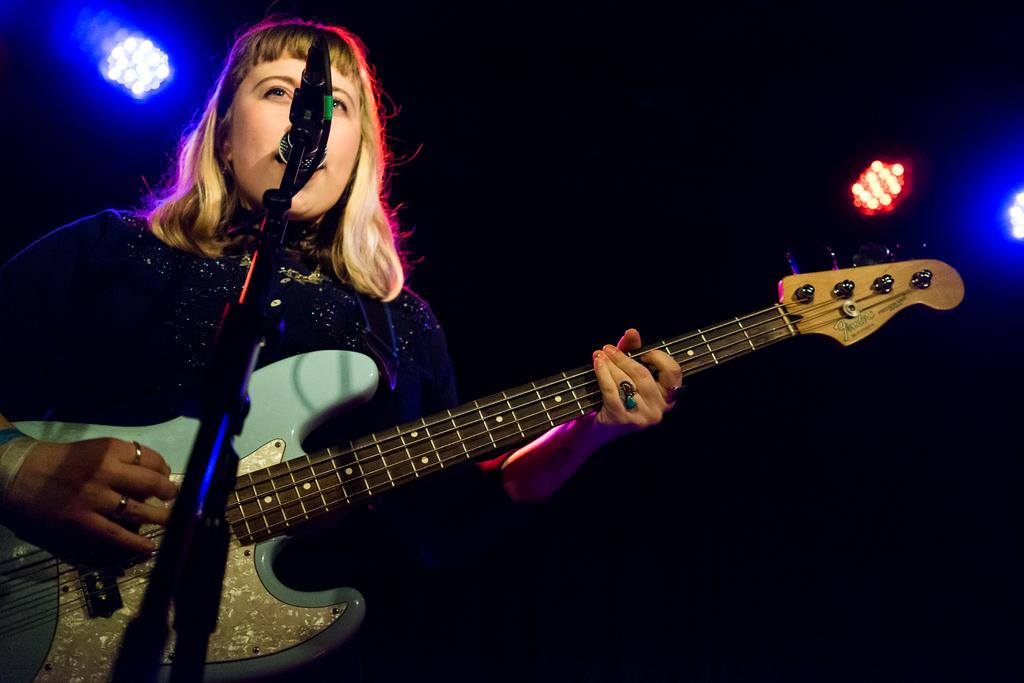What can be seen at the top of the image? There are lights visible at the top of the image. How would you describe the overall lighting in the image? The background of the image is dark. Who is present in the image? There are women in the image. What are the women doing in the image? The women are standing in front of a microphone and singing. Are any musical instruments being played in the image? Yes, one of the women is playing a guitar. What type of flowers can be seen in the image? There are no flowers present in the image. In which direction are the women facing in the image? The provided facts do not specify the direction the women are facing, so it cannot be determined from the image. 